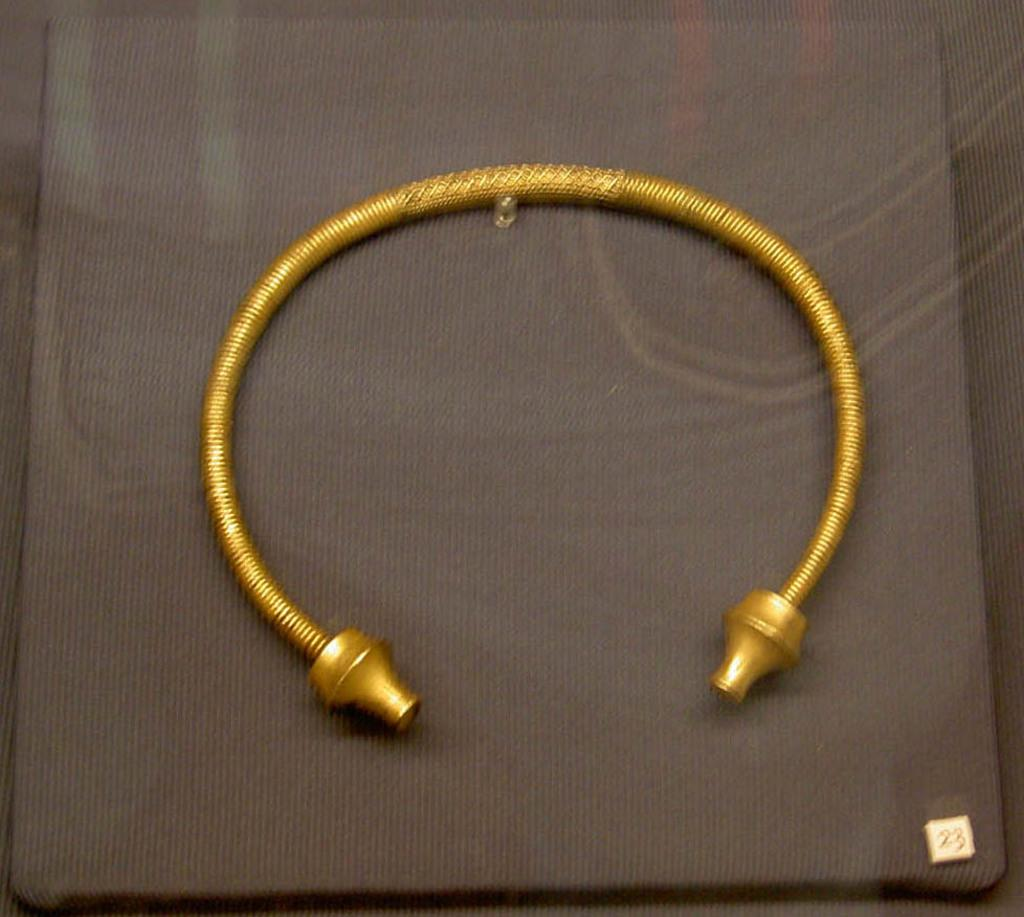What type of items can be seen in the image? There is jewelry in the image. How is the jewelry arranged or displayed in the image? The jewelry is placed on a board. What type of beast is present in the image? There is no beast present in the image; it only features jewelry placed on a board. 